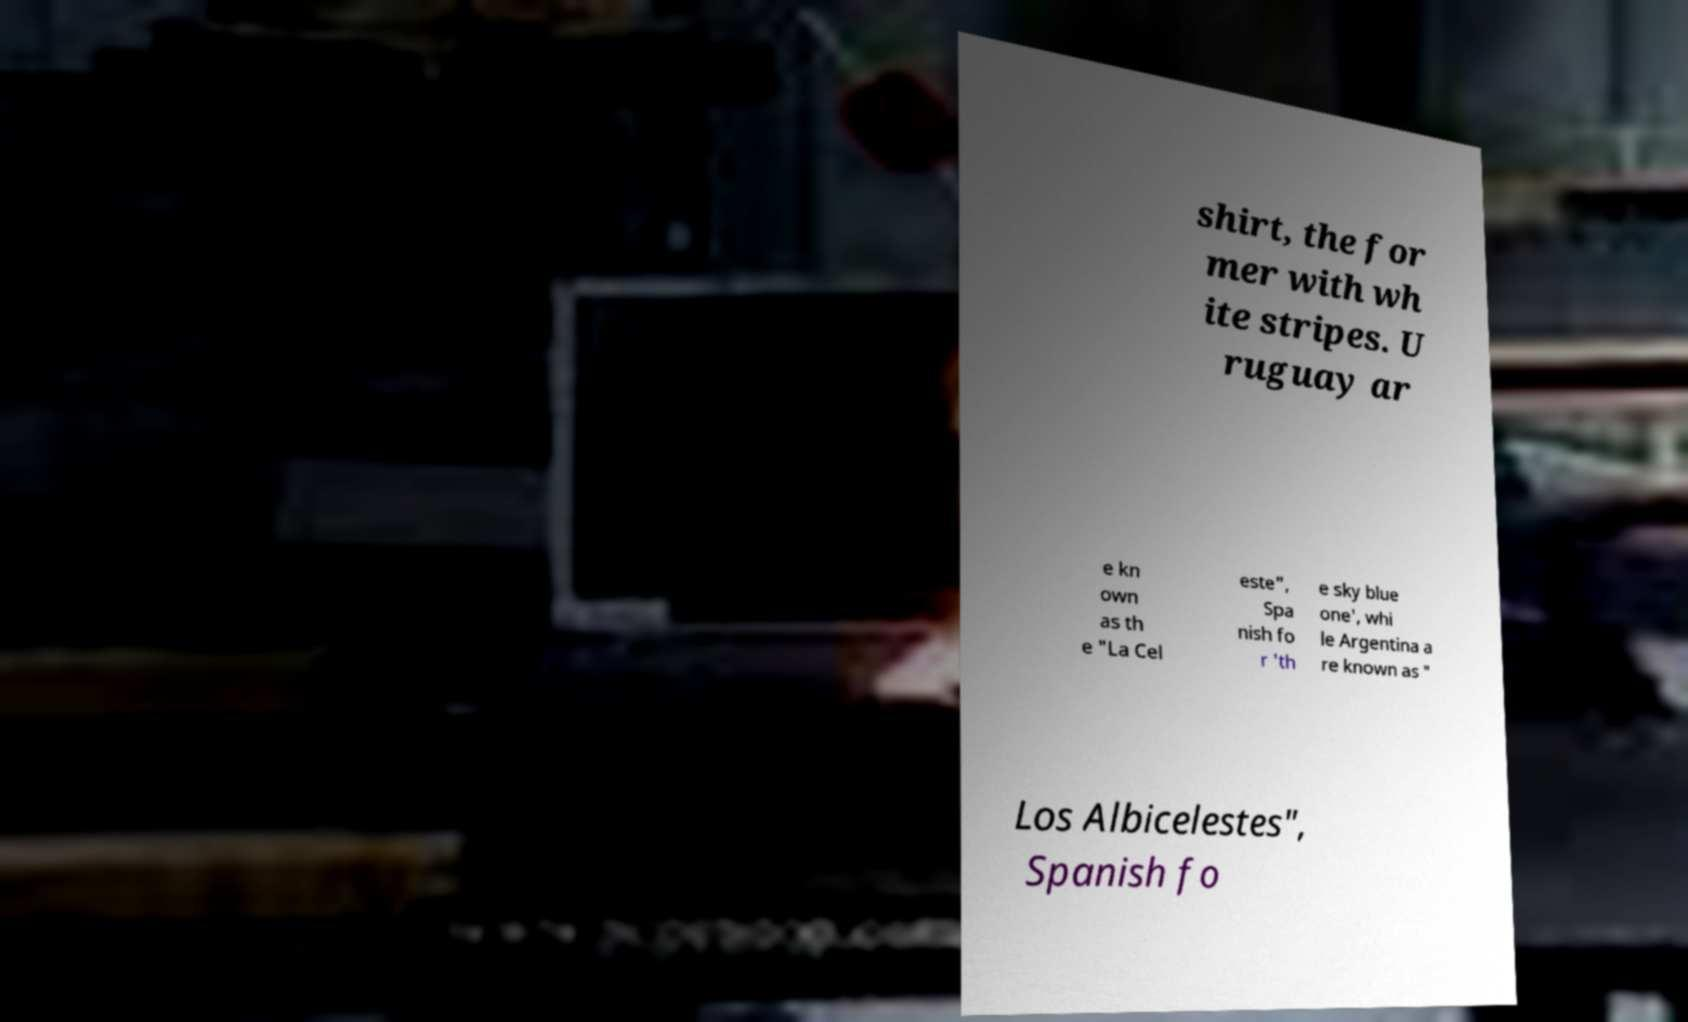Could you assist in decoding the text presented in this image and type it out clearly? shirt, the for mer with wh ite stripes. U ruguay ar e kn own as th e "La Cel este", Spa nish fo r 'th e sky blue one', whi le Argentina a re known as " Los Albicelestes", Spanish fo 